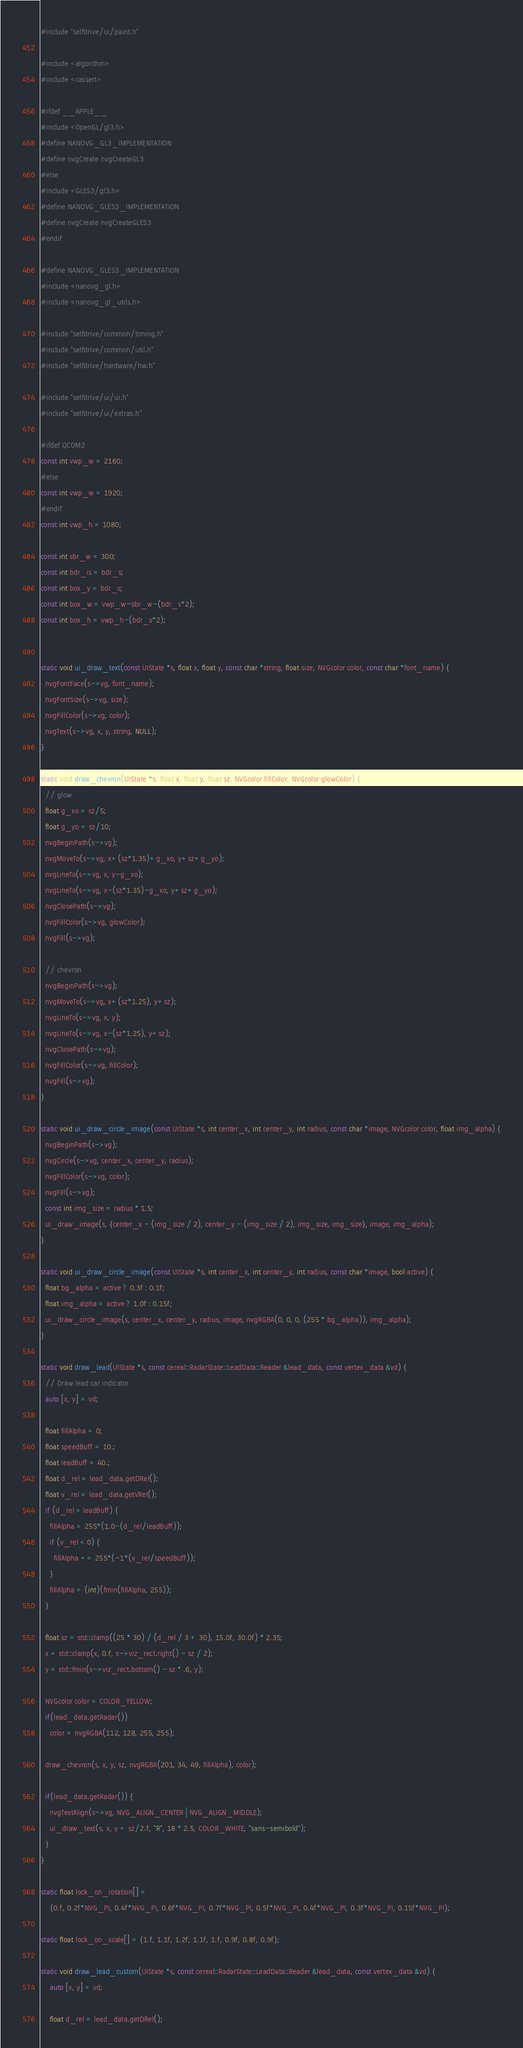Convert code to text. <code><loc_0><loc_0><loc_500><loc_500><_C++_>#include "selfdrive/ui/paint.h"

#include <algorithm>
#include <cassert>

#ifdef __APPLE__
#include <OpenGL/gl3.h>
#define NANOVG_GL3_IMPLEMENTATION
#define nvgCreate nvgCreateGL3
#else
#include <GLES3/gl3.h>
#define NANOVG_GLES3_IMPLEMENTATION
#define nvgCreate nvgCreateGLES3
#endif

#define NANOVG_GLES3_IMPLEMENTATION
#include <nanovg_gl.h>
#include <nanovg_gl_utils.h>

#include "selfdrive/common/timing.h"
#include "selfdrive/common/util.h"
#include "selfdrive/hardware/hw.h"

#include "selfdrive/ui/ui.h"
#include "selfdrive/ui/extras.h"

#ifdef QCOM2
const int vwp_w = 2160;
#else
const int vwp_w = 1920;
#endif
const int vwp_h = 1080;

const int sbr_w = 300;
const int bdr_is = bdr_s;
const int box_y = bdr_s;
const int box_w = vwp_w-sbr_w-(bdr_s*2);
const int box_h = vwp_h-(bdr_s*2);


static void ui_draw_text(const UIState *s, float x, float y, const char *string, float size, NVGcolor color, const char *font_name) {
  nvgFontFace(s->vg, font_name);
  nvgFontSize(s->vg, size);
  nvgFillColor(s->vg, color);
  nvgText(s->vg, x, y, string, NULL);
}

static void draw_chevron(UIState *s, float x, float y, float sz, NVGcolor fillColor, NVGcolor glowColor) {
  // glow
  float g_xo = sz/5;
  float g_yo = sz/10;
  nvgBeginPath(s->vg);
  nvgMoveTo(s->vg, x+(sz*1.35)+g_xo, y+sz+g_yo);
  nvgLineTo(s->vg, x, y-g_xo);
  nvgLineTo(s->vg, x-(sz*1.35)-g_xo, y+sz+g_yo);
  nvgClosePath(s->vg);
  nvgFillColor(s->vg, glowColor);
  nvgFill(s->vg);

  // chevron
  nvgBeginPath(s->vg);
  nvgMoveTo(s->vg, x+(sz*1.25), y+sz);
  nvgLineTo(s->vg, x, y);
  nvgLineTo(s->vg, x-(sz*1.25), y+sz);
  nvgClosePath(s->vg);
  nvgFillColor(s->vg, fillColor);
  nvgFill(s->vg);
}

static void ui_draw_circle_image(const UIState *s, int center_x, int center_y, int radius, const char *image, NVGcolor color, float img_alpha) {
  nvgBeginPath(s->vg);
  nvgCircle(s->vg, center_x, center_y, radius);
  nvgFillColor(s->vg, color);
  nvgFill(s->vg);
  const int img_size = radius * 1.5;
  ui_draw_image(s, {center_x - (img_size / 2), center_y - (img_size / 2), img_size, img_size}, image, img_alpha);
}

static void ui_draw_circle_image(const UIState *s, int center_x, int center_y, int radius, const char *image, bool active) {
  float bg_alpha = active ? 0.3f : 0.1f;
  float img_alpha = active ? 1.0f : 0.15f;
  ui_draw_circle_image(s, center_x, center_y, radius, image, nvgRGBA(0, 0, 0, (255 * bg_alpha)), img_alpha);
}

static void draw_lead(UIState *s, const cereal::RadarState::LeadData::Reader &lead_data, const vertex_data &vd) {
  // Draw lead car indicator
  auto [x, y] = vd;

  float fillAlpha = 0;
  float speedBuff = 10.;
  float leadBuff = 40.;
  float d_rel = lead_data.getDRel();
  float v_rel = lead_data.getVRel();
  if (d_rel < leadBuff) {
    fillAlpha = 255*(1.0-(d_rel/leadBuff));
    if (v_rel < 0) {
      fillAlpha += 255*(-1*(v_rel/speedBuff));
    }
    fillAlpha = (int)(fmin(fillAlpha, 255));
  }

  float sz = std::clamp((25 * 30) / (d_rel / 3 + 30), 15.0f, 30.0f) * 2.35;
  x = std::clamp(x, 0.f, s->viz_rect.right() - sz / 2);
  y = std::fmin(s->viz_rect.bottom() - sz * .6, y);

  NVGcolor color = COLOR_YELLOW;
  if(lead_data.getRadar())
    color = nvgRGBA(112, 128, 255, 255);

  draw_chevron(s, x, y, sz, nvgRGBA(201, 34, 49, fillAlpha), color);

  if(lead_data.getRadar()) {
    nvgTextAlign(s->vg, NVG_ALIGN_CENTER | NVG_ALIGN_MIDDLE);
    ui_draw_text(s, x, y + sz/2.f, "R", 18 * 2.5, COLOR_WHITE, "sans-semibold");
  }
}

static float lock_on_rotation[] =
    {0.f, 0.2f*NVG_PI, 0.4f*NVG_PI, 0.6f*NVG_PI, 0.7f*NVG_PI, 0.5f*NVG_PI, 0.4f*NVG_PI, 0.3f*NVG_PI, 0.15f*NVG_PI};

static float lock_on_scale[] = {1.f, 1.1f, 1.2f, 1.1f, 1.f, 0.9f, 0.8f, 0.9f};

static void draw_lead_custom(UIState *s, const cereal::RadarState::LeadData::Reader &lead_data, const vertex_data &vd) {
    auto [x, y] = vd;

    float d_rel = lead_data.getDRel();
</code> 